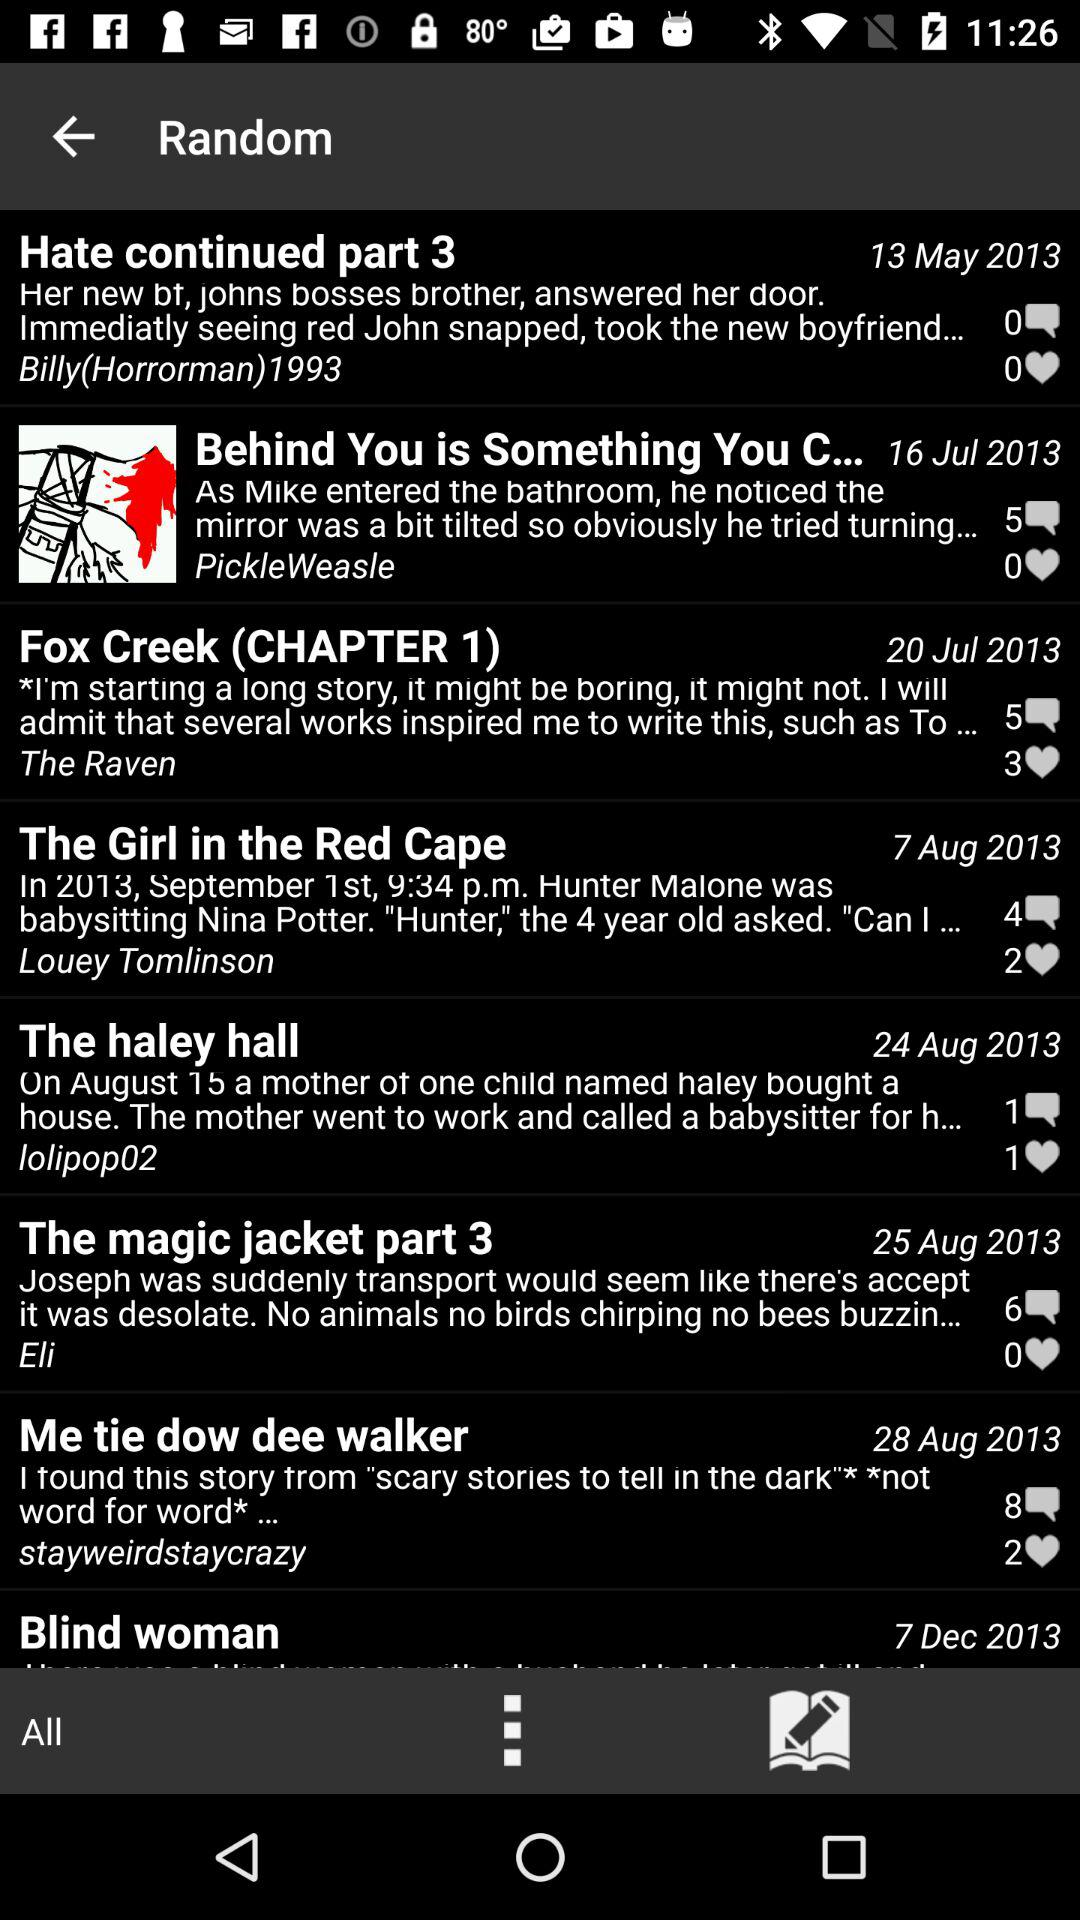Which post was posted on 25 August 2013? The post that was posted on 25 August 2013 was "The magic jacket part 3". 